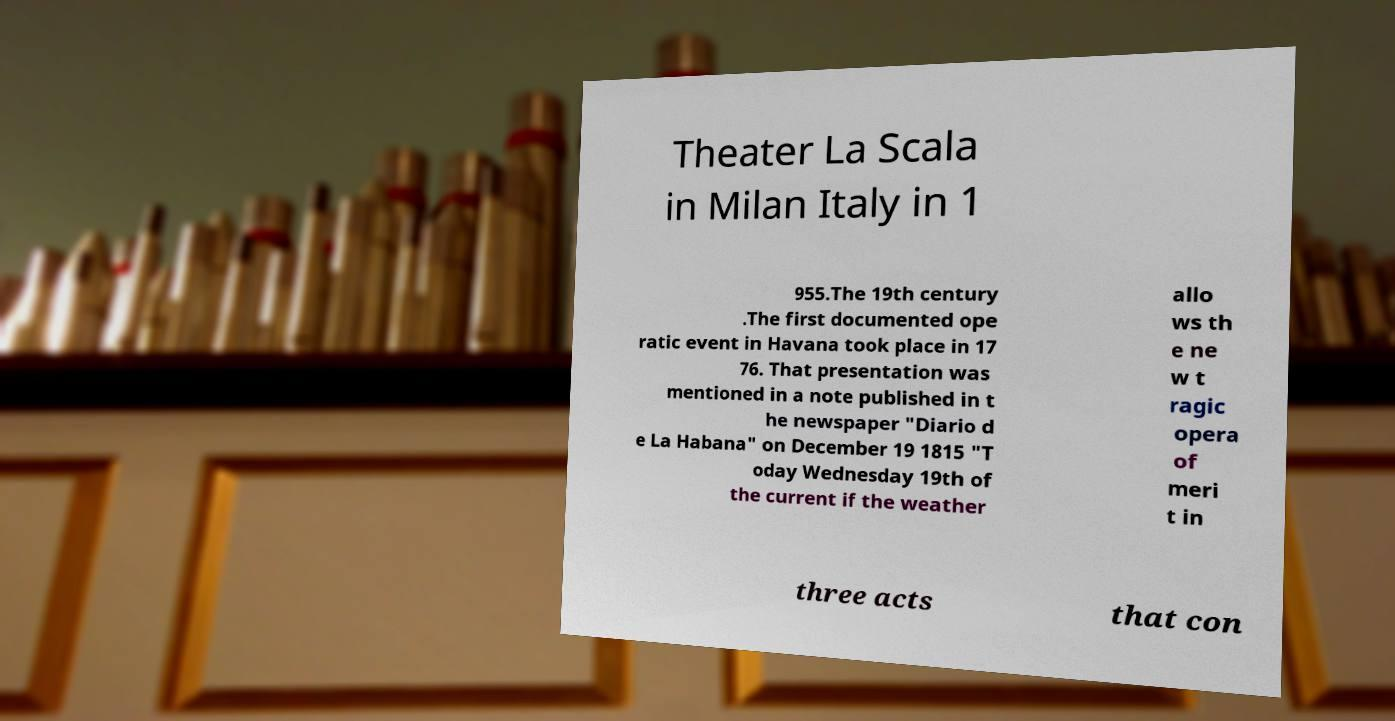For documentation purposes, I need the text within this image transcribed. Could you provide that? Theater La Scala in Milan Italy in 1 955.The 19th century .The first documented ope ratic event in Havana took place in 17 76. That presentation was mentioned in a note published in t he newspaper "Diario d e La Habana" on December 19 1815 "T oday Wednesday 19th of the current if the weather allo ws th e ne w t ragic opera of meri t in three acts that con 